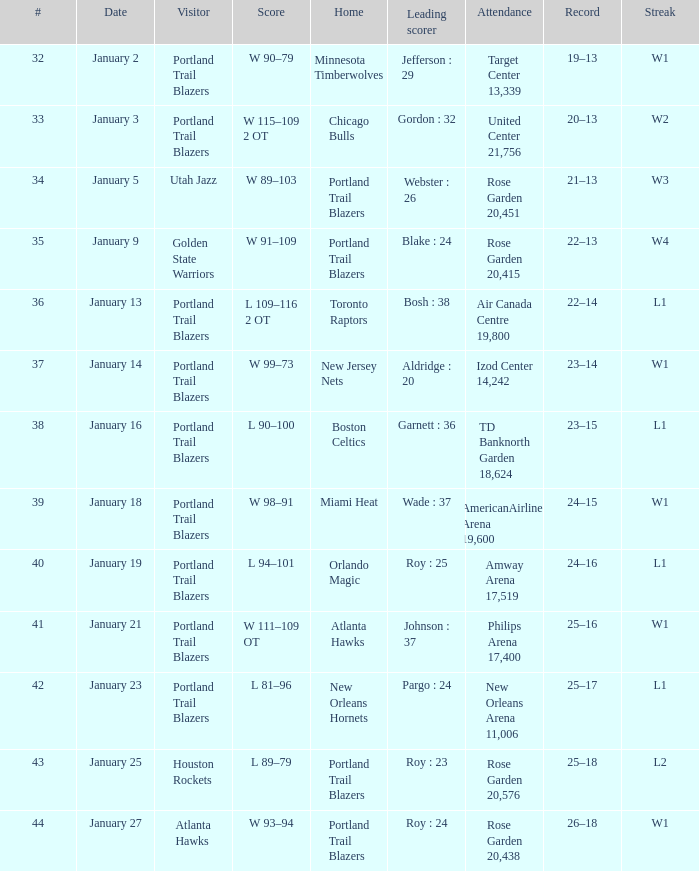What are all the records having a score between 98-91? 24–15. 